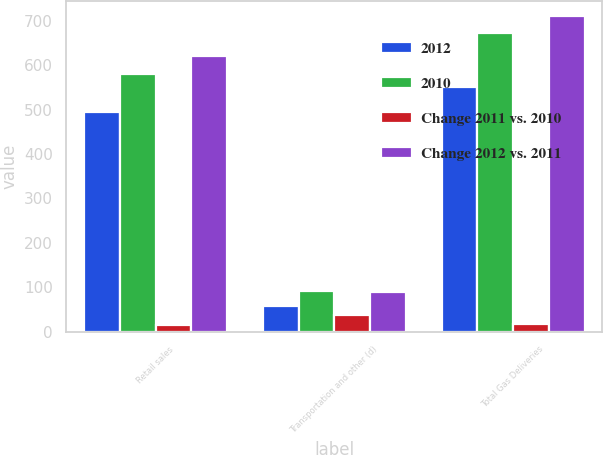<chart> <loc_0><loc_0><loc_500><loc_500><stacked_bar_chart><ecel><fcel>Retail sales<fcel>Transportation and other (d)<fcel>Total Gas Deliveries<nl><fcel>2012<fcel>494<fcel>58<fcel>552<nl><fcel>2010<fcel>580<fcel>92<fcel>672<nl><fcel>Change 2011 vs. 2010<fcel>14.8<fcel>37<fcel>17.9<nl><fcel>Change 2012 vs. 2011<fcel>620<fcel>90<fcel>710<nl></chart> 